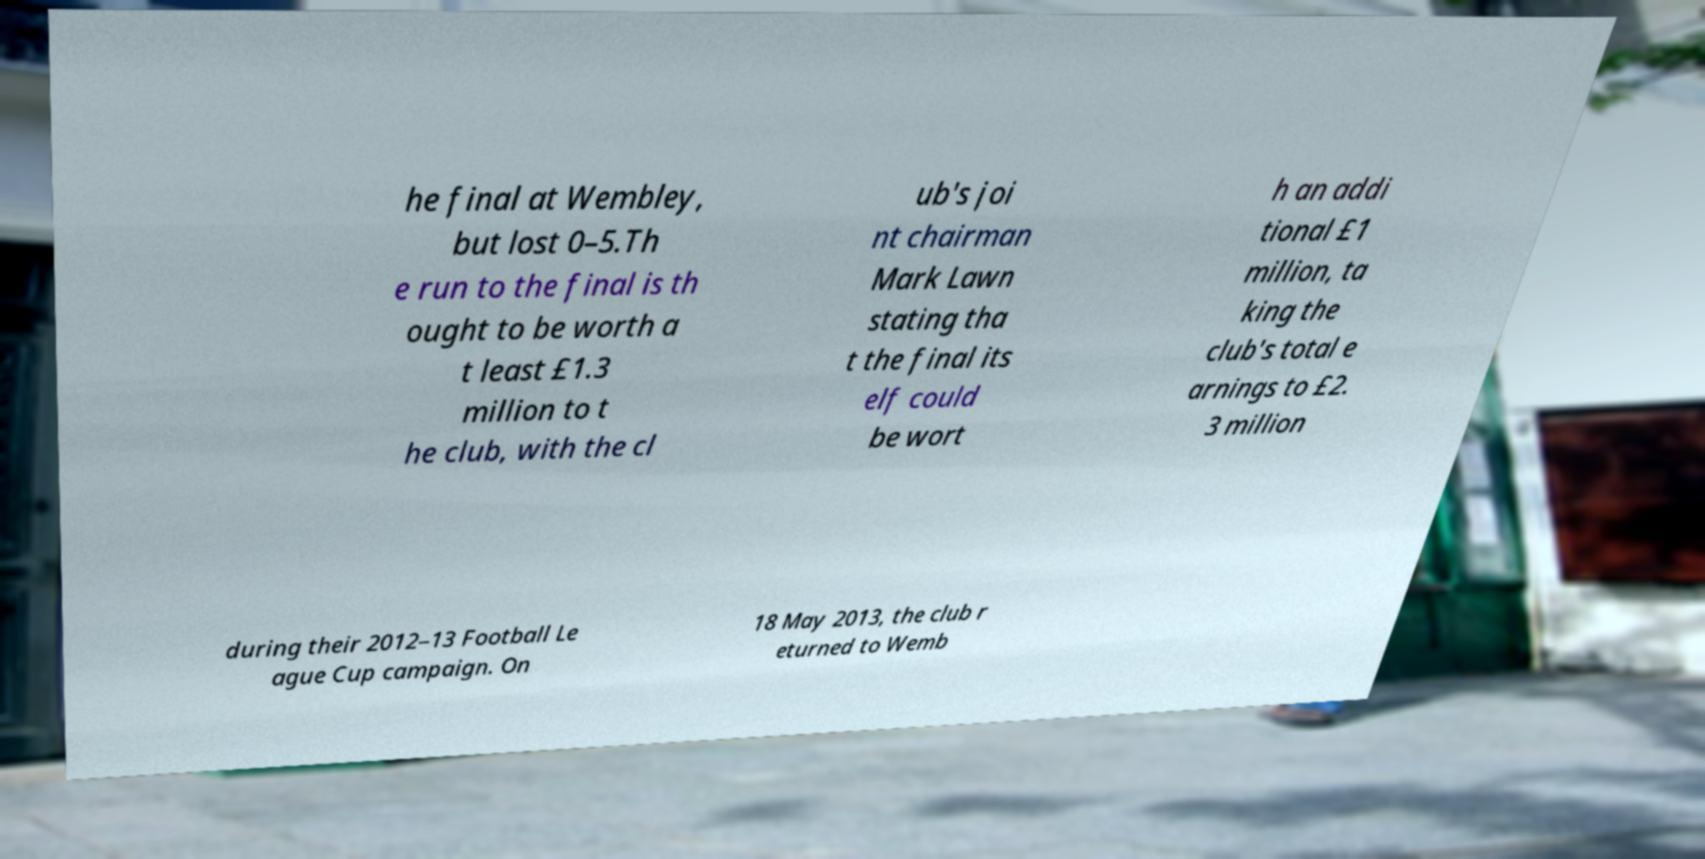Can you accurately transcribe the text from the provided image for me? he final at Wembley, but lost 0–5.Th e run to the final is th ought to be worth a t least £1.3 million to t he club, with the cl ub's joi nt chairman Mark Lawn stating tha t the final its elf could be wort h an addi tional £1 million, ta king the club's total e arnings to £2. 3 million during their 2012–13 Football Le ague Cup campaign. On 18 May 2013, the club r eturned to Wemb 